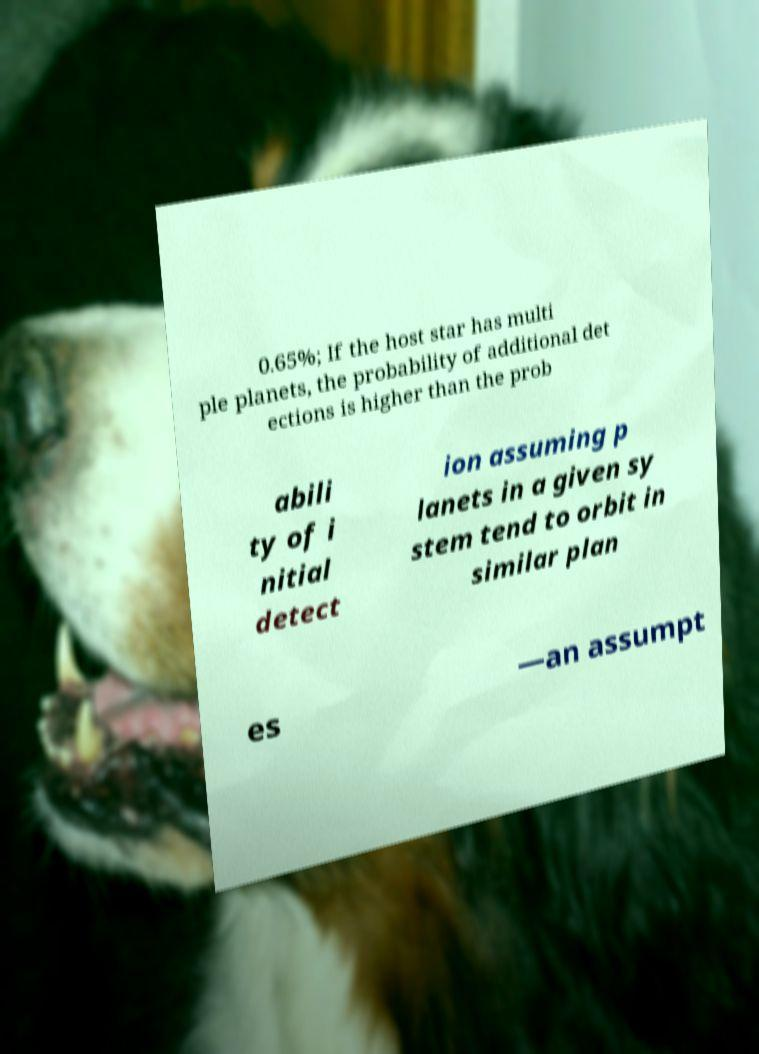There's text embedded in this image that I need extracted. Can you transcribe it verbatim? 0.65%; If the host star has multi ple planets, the probability of additional det ections is higher than the prob abili ty of i nitial detect ion assuming p lanets in a given sy stem tend to orbit in similar plan es —an assumpt 